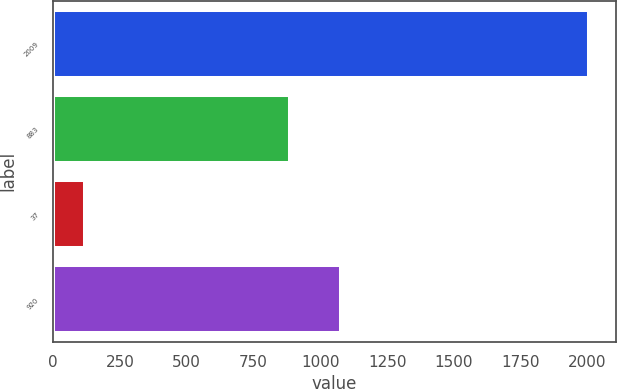Convert chart. <chart><loc_0><loc_0><loc_500><loc_500><bar_chart><fcel>2009<fcel>883<fcel>37<fcel>920<nl><fcel>2007<fcel>888<fcel>120<fcel>1076.7<nl></chart> 